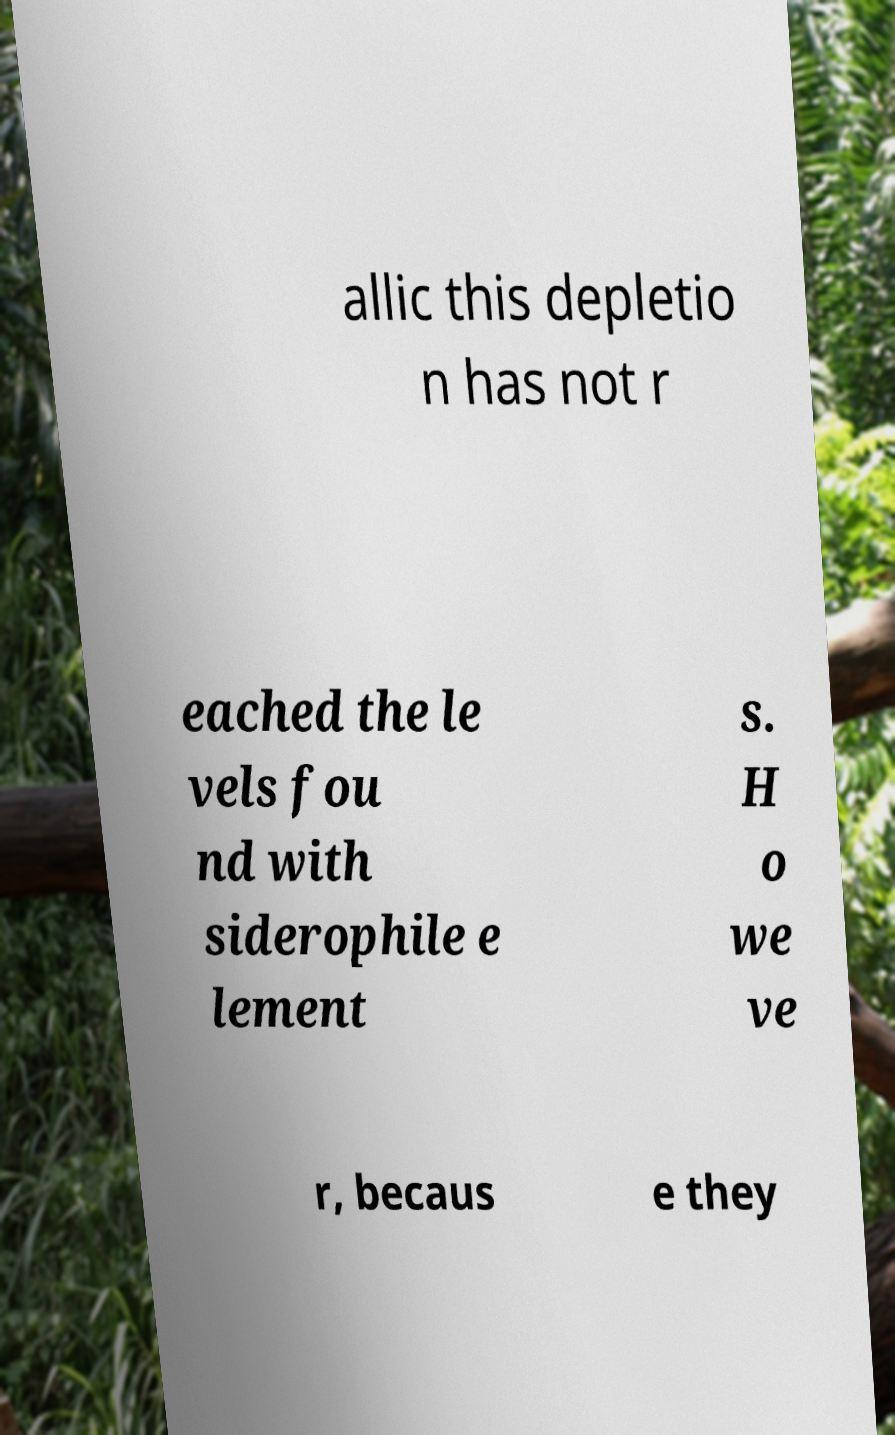I need the written content from this picture converted into text. Can you do that? allic this depletio n has not r eached the le vels fou nd with siderophile e lement s. H o we ve r, becaus e they 